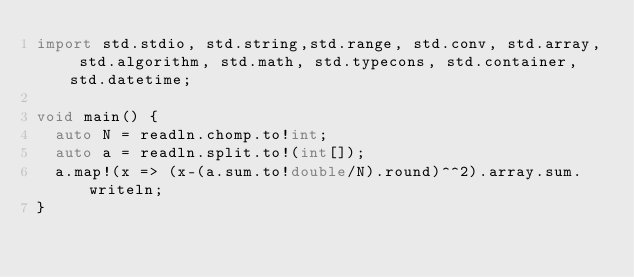Convert code to text. <code><loc_0><loc_0><loc_500><loc_500><_D_>import std.stdio, std.string,std.range, std.conv, std.array, std.algorithm, std.math, std.typecons, std.container, std.datetime;

void main() {
  auto N = readln.chomp.to!int;
  auto a = readln.split.to!(int[]);
  a.map!(x => (x-(a.sum.to!double/N).round)^^2).array.sum.writeln;
}
</code> 